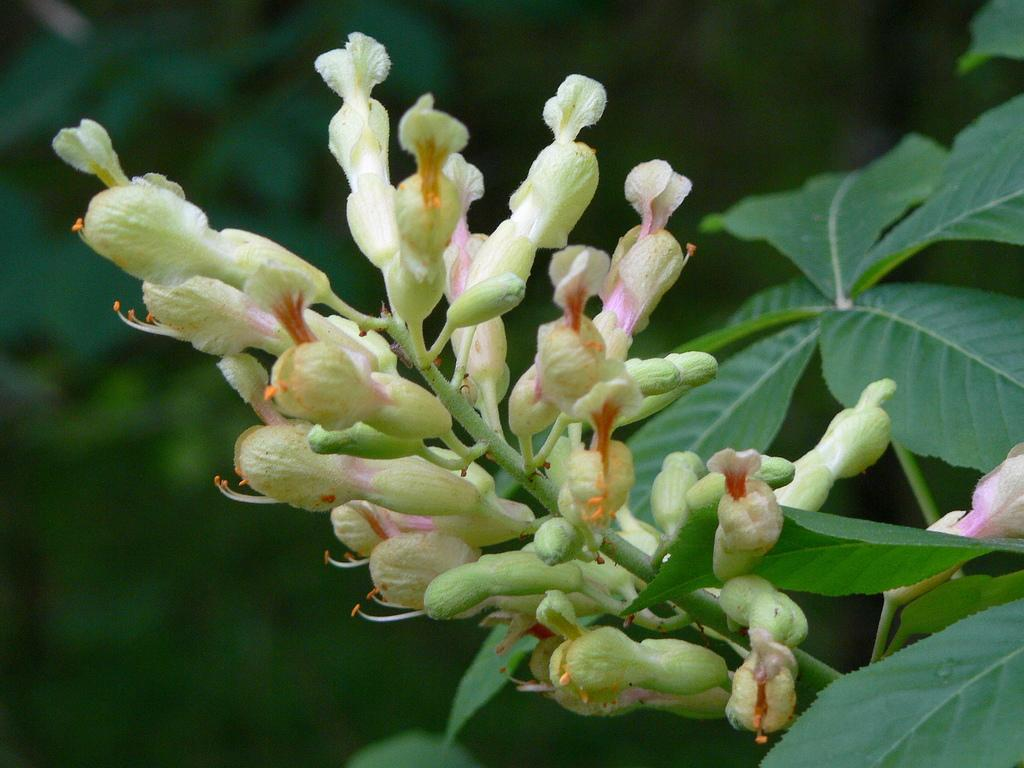What is the main subject of the image? The main subject of the image is a bunch of flower buds. What can be observed about the flower buds' stems? The flower buds have leaves attached to their stems. How would you describe the background of the image? The background of the image appears green and is blurred. Is there a volcano erupting in the background of the image? No, there is no volcano present in the image. What decision is being made by the flower buds in the image? Flower buds do not make decisions, as they are inanimate objects. 